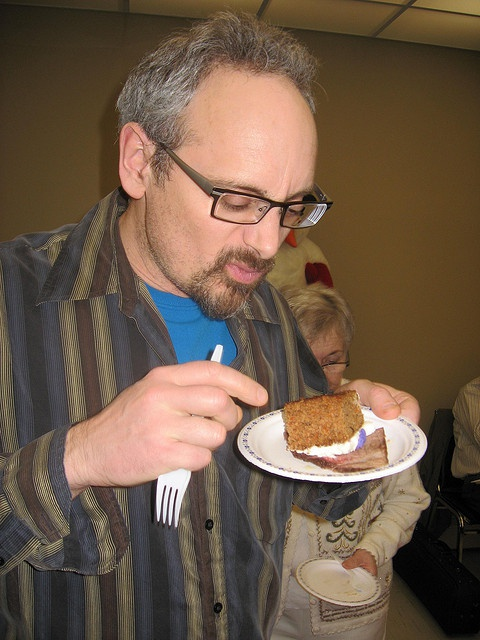Describe the objects in this image and their specific colors. I can see people in black, gray, tan, and maroon tones, people in black, tan, maroon, and gray tones, cake in black, tan, red, and salmon tones, people in black and gray tones, and chair in black, darkgreen, and tan tones in this image. 